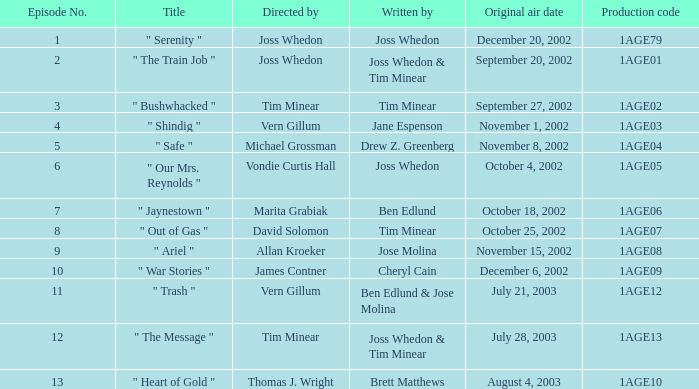What is the production number for the episode authored by drew z. greenberg? 1AGE04. 